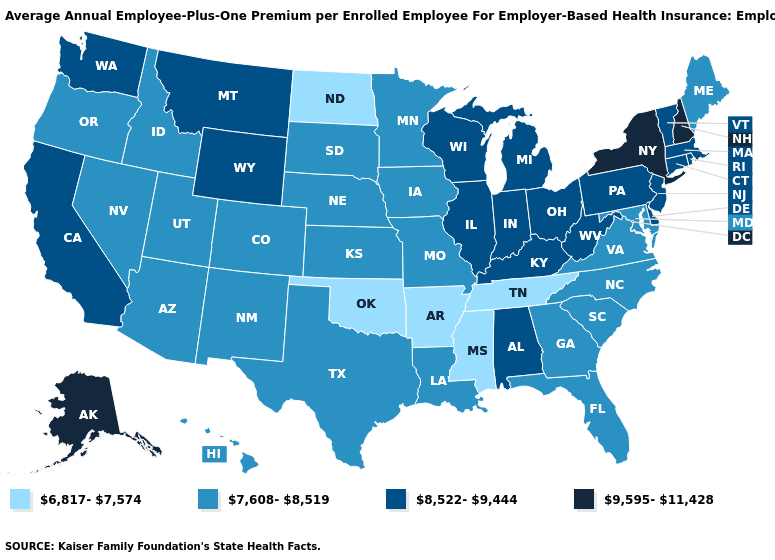Name the states that have a value in the range 9,595-11,428?
Quick response, please. Alaska, New Hampshire, New York. Which states have the lowest value in the USA?
Quick response, please. Arkansas, Mississippi, North Dakota, Oklahoma, Tennessee. Among the states that border Delaware , does Pennsylvania have the lowest value?
Keep it brief. No. Name the states that have a value in the range 6,817-7,574?
Be succinct. Arkansas, Mississippi, North Dakota, Oklahoma, Tennessee. Does West Virginia have the highest value in the South?
Short answer required. Yes. Which states have the highest value in the USA?
Write a very short answer. Alaska, New Hampshire, New York. What is the value of Hawaii?
Be succinct. 7,608-8,519. Does Maryland have the highest value in the South?
Quick response, please. No. What is the highest value in states that border Iowa?
Be succinct. 8,522-9,444. What is the highest value in states that border Delaware?
Concise answer only. 8,522-9,444. What is the value of Texas?
Quick response, please. 7,608-8,519. Does Oklahoma have the highest value in the USA?
Short answer required. No. Name the states that have a value in the range 8,522-9,444?
Give a very brief answer. Alabama, California, Connecticut, Delaware, Illinois, Indiana, Kentucky, Massachusetts, Michigan, Montana, New Jersey, Ohio, Pennsylvania, Rhode Island, Vermont, Washington, West Virginia, Wisconsin, Wyoming. What is the value of North Dakota?
Write a very short answer. 6,817-7,574. What is the value of Colorado?
Quick response, please. 7,608-8,519. 